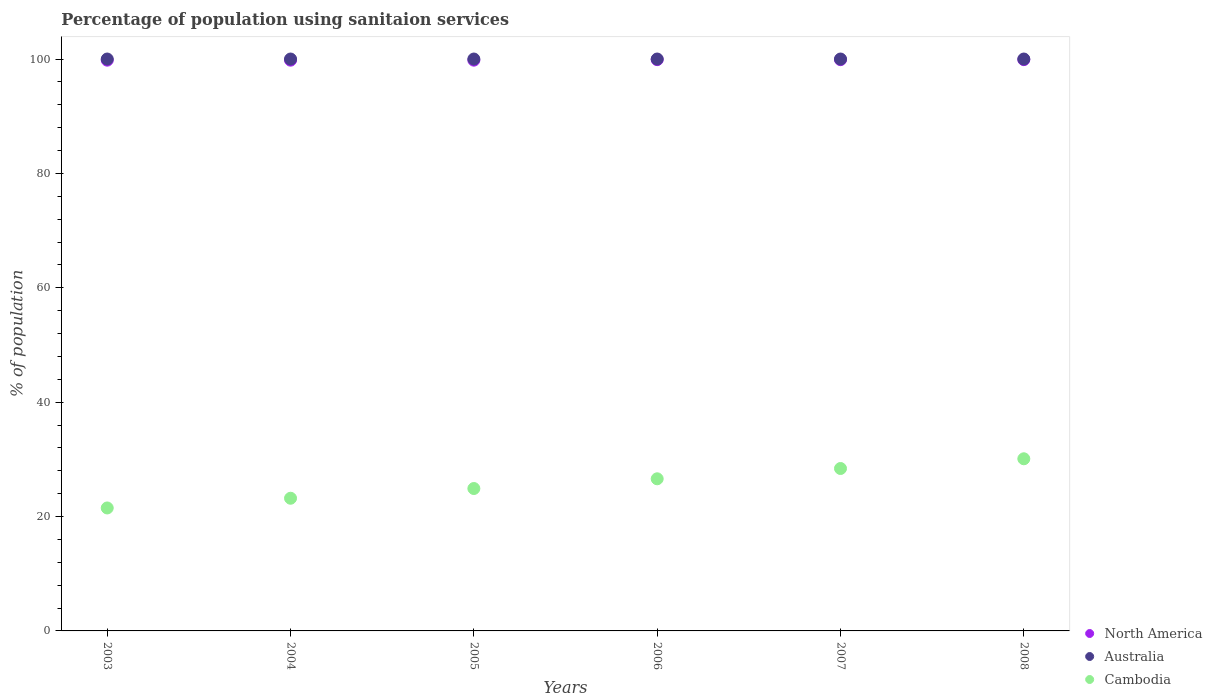How many different coloured dotlines are there?
Keep it short and to the point. 3. Is the number of dotlines equal to the number of legend labels?
Your answer should be very brief. Yes. What is the percentage of population using sanitaion services in Australia in 2004?
Your response must be concise. 100. Across all years, what is the maximum percentage of population using sanitaion services in Australia?
Your answer should be compact. 100. Across all years, what is the minimum percentage of population using sanitaion services in Cambodia?
Keep it short and to the point. 21.5. In which year was the percentage of population using sanitaion services in Cambodia maximum?
Ensure brevity in your answer.  2008. In which year was the percentage of population using sanitaion services in Cambodia minimum?
Offer a terse response. 2003. What is the total percentage of population using sanitaion services in North America in the graph?
Your response must be concise. 599.07. What is the difference between the percentage of population using sanitaion services in Cambodia in 2003 and the percentage of population using sanitaion services in Australia in 2008?
Your response must be concise. -78.5. In the year 2008, what is the difference between the percentage of population using sanitaion services in North America and percentage of population using sanitaion services in Australia?
Provide a short and direct response. -0.11. What is the ratio of the percentage of population using sanitaion services in Cambodia in 2003 to that in 2005?
Keep it short and to the point. 0.86. What is the difference between the highest and the lowest percentage of population using sanitaion services in Cambodia?
Provide a short and direct response. 8.6. In how many years, is the percentage of population using sanitaion services in Cambodia greater than the average percentage of population using sanitaion services in Cambodia taken over all years?
Keep it short and to the point. 3. Does the percentage of population using sanitaion services in North America monotonically increase over the years?
Offer a terse response. No. Is the percentage of population using sanitaion services in Australia strictly less than the percentage of population using sanitaion services in Cambodia over the years?
Make the answer very short. No. How many dotlines are there?
Ensure brevity in your answer.  3. What is the difference between two consecutive major ticks on the Y-axis?
Your answer should be very brief. 20. Does the graph contain grids?
Offer a terse response. No. Where does the legend appear in the graph?
Keep it short and to the point. Bottom right. How many legend labels are there?
Keep it short and to the point. 3. How are the legend labels stacked?
Offer a very short reply. Vertical. What is the title of the graph?
Make the answer very short. Percentage of population using sanitaion services. What is the label or title of the X-axis?
Offer a very short reply. Years. What is the label or title of the Y-axis?
Your answer should be very brief. % of population. What is the % of population of North America in 2003?
Give a very brief answer. 99.8. What is the % of population of North America in 2004?
Keep it short and to the point. 99.8. What is the % of population in Australia in 2004?
Ensure brevity in your answer.  100. What is the % of population of Cambodia in 2004?
Provide a succinct answer. 23.2. What is the % of population in North America in 2005?
Your answer should be compact. 99.8. What is the % of population in Australia in 2005?
Offer a very short reply. 100. What is the % of population of Cambodia in 2005?
Offer a very short reply. 24.9. What is the % of population of North America in 2006?
Offer a terse response. 99.89. What is the % of population in Cambodia in 2006?
Your response must be concise. 26.6. What is the % of population in North America in 2007?
Provide a succinct answer. 99.89. What is the % of population in Australia in 2007?
Make the answer very short. 100. What is the % of population in Cambodia in 2007?
Provide a succinct answer. 28.4. What is the % of population of North America in 2008?
Your answer should be compact. 99.89. What is the % of population in Cambodia in 2008?
Make the answer very short. 30.1. Across all years, what is the maximum % of population of North America?
Give a very brief answer. 99.89. Across all years, what is the maximum % of population in Cambodia?
Your response must be concise. 30.1. Across all years, what is the minimum % of population of North America?
Your response must be concise. 99.8. Across all years, what is the minimum % of population in Cambodia?
Provide a succinct answer. 21.5. What is the total % of population in North America in the graph?
Provide a succinct answer. 599.07. What is the total % of population of Australia in the graph?
Your answer should be very brief. 600. What is the total % of population in Cambodia in the graph?
Ensure brevity in your answer.  154.7. What is the difference between the % of population of Australia in 2003 and that in 2004?
Keep it short and to the point. 0. What is the difference between the % of population in Cambodia in 2003 and that in 2004?
Your response must be concise. -1.7. What is the difference between the % of population in Cambodia in 2003 and that in 2005?
Provide a succinct answer. -3.4. What is the difference between the % of population of North America in 2003 and that in 2006?
Give a very brief answer. -0.09. What is the difference between the % of population in North America in 2003 and that in 2007?
Offer a very short reply. -0.09. What is the difference between the % of population of North America in 2003 and that in 2008?
Provide a short and direct response. -0.09. What is the difference between the % of population in Australia in 2004 and that in 2005?
Make the answer very short. 0. What is the difference between the % of population in North America in 2004 and that in 2006?
Your answer should be compact. -0.09. What is the difference between the % of population of Australia in 2004 and that in 2006?
Your answer should be compact. 0. What is the difference between the % of population of Cambodia in 2004 and that in 2006?
Give a very brief answer. -3.4. What is the difference between the % of population in North America in 2004 and that in 2007?
Provide a short and direct response. -0.09. What is the difference between the % of population of Cambodia in 2004 and that in 2007?
Offer a terse response. -5.2. What is the difference between the % of population in North America in 2004 and that in 2008?
Provide a short and direct response. -0.09. What is the difference between the % of population of North America in 2005 and that in 2006?
Your response must be concise. -0.09. What is the difference between the % of population in Australia in 2005 and that in 2006?
Provide a succinct answer. 0. What is the difference between the % of population in Cambodia in 2005 and that in 2006?
Ensure brevity in your answer.  -1.7. What is the difference between the % of population in North America in 2005 and that in 2007?
Ensure brevity in your answer.  -0.09. What is the difference between the % of population of Australia in 2005 and that in 2007?
Keep it short and to the point. 0. What is the difference between the % of population in North America in 2005 and that in 2008?
Keep it short and to the point. -0.09. What is the difference between the % of population of Australia in 2005 and that in 2008?
Provide a succinct answer. 0. What is the difference between the % of population in North America in 2006 and that in 2007?
Your answer should be compact. 0. What is the difference between the % of population of Cambodia in 2006 and that in 2008?
Ensure brevity in your answer.  -3.5. What is the difference between the % of population of Australia in 2007 and that in 2008?
Offer a terse response. 0. What is the difference between the % of population of North America in 2003 and the % of population of Australia in 2004?
Make the answer very short. -0.2. What is the difference between the % of population of North America in 2003 and the % of population of Cambodia in 2004?
Offer a terse response. 76.6. What is the difference between the % of population in Australia in 2003 and the % of population in Cambodia in 2004?
Give a very brief answer. 76.8. What is the difference between the % of population of North America in 2003 and the % of population of Cambodia in 2005?
Offer a very short reply. 74.9. What is the difference between the % of population in Australia in 2003 and the % of population in Cambodia in 2005?
Make the answer very short. 75.1. What is the difference between the % of population of North America in 2003 and the % of population of Cambodia in 2006?
Provide a short and direct response. 73.2. What is the difference between the % of population in Australia in 2003 and the % of population in Cambodia in 2006?
Give a very brief answer. 73.4. What is the difference between the % of population of North America in 2003 and the % of population of Cambodia in 2007?
Offer a very short reply. 71.4. What is the difference between the % of population of Australia in 2003 and the % of population of Cambodia in 2007?
Your response must be concise. 71.6. What is the difference between the % of population of North America in 2003 and the % of population of Cambodia in 2008?
Offer a terse response. 69.7. What is the difference between the % of population of Australia in 2003 and the % of population of Cambodia in 2008?
Provide a short and direct response. 69.9. What is the difference between the % of population in North America in 2004 and the % of population in Cambodia in 2005?
Give a very brief answer. 74.9. What is the difference between the % of population in Australia in 2004 and the % of population in Cambodia in 2005?
Your answer should be compact. 75.1. What is the difference between the % of population of North America in 2004 and the % of population of Australia in 2006?
Ensure brevity in your answer.  -0.2. What is the difference between the % of population of North America in 2004 and the % of population of Cambodia in 2006?
Offer a very short reply. 73.2. What is the difference between the % of population of Australia in 2004 and the % of population of Cambodia in 2006?
Ensure brevity in your answer.  73.4. What is the difference between the % of population of North America in 2004 and the % of population of Cambodia in 2007?
Your response must be concise. 71.4. What is the difference between the % of population in Australia in 2004 and the % of population in Cambodia in 2007?
Ensure brevity in your answer.  71.6. What is the difference between the % of population in North America in 2004 and the % of population in Australia in 2008?
Offer a terse response. -0.2. What is the difference between the % of population of North America in 2004 and the % of population of Cambodia in 2008?
Give a very brief answer. 69.7. What is the difference between the % of population of Australia in 2004 and the % of population of Cambodia in 2008?
Ensure brevity in your answer.  69.9. What is the difference between the % of population in North America in 2005 and the % of population in Cambodia in 2006?
Your response must be concise. 73.2. What is the difference between the % of population of Australia in 2005 and the % of population of Cambodia in 2006?
Your response must be concise. 73.4. What is the difference between the % of population of North America in 2005 and the % of population of Cambodia in 2007?
Keep it short and to the point. 71.4. What is the difference between the % of population of Australia in 2005 and the % of population of Cambodia in 2007?
Provide a short and direct response. 71.6. What is the difference between the % of population in North America in 2005 and the % of population in Cambodia in 2008?
Keep it short and to the point. 69.7. What is the difference between the % of population of Australia in 2005 and the % of population of Cambodia in 2008?
Your response must be concise. 69.9. What is the difference between the % of population of North America in 2006 and the % of population of Australia in 2007?
Ensure brevity in your answer.  -0.11. What is the difference between the % of population in North America in 2006 and the % of population in Cambodia in 2007?
Make the answer very short. 71.49. What is the difference between the % of population of Australia in 2006 and the % of population of Cambodia in 2007?
Keep it short and to the point. 71.6. What is the difference between the % of population in North America in 2006 and the % of population in Australia in 2008?
Offer a very short reply. -0.11. What is the difference between the % of population in North America in 2006 and the % of population in Cambodia in 2008?
Provide a short and direct response. 69.79. What is the difference between the % of population in Australia in 2006 and the % of population in Cambodia in 2008?
Make the answer very short. 69.9. What is the difference between the % of population in North America in 2007 and the % of population in Australia in 2008?
Give a very brief answer. -0.11. What is the difference between the % of population in North America in 2007 and the % of population in Cambodia in 2008?
Make the answer very short. 69.79. What is the difference between the % of population in Australia in 2007 and the % of population in Cambodia in 2008?
Offer a very short reply. 69.9. What is the average % of population in North America per year?
Provide a succinct answer. 99.85. What is the average % of population of Australia per year?
Give a very brief answer. 100. What is the average % of population in Cambodia per year?
Give a very brief answer. 25.78. In the year 2003, what is the difference between the % of population of North America and % of population of Cambodia?
Your answer should be very brief. 78.3. In the year 2003, what is the difference between the % of population of Australia and % of population of Cambodia?
Provide a succinct answer. 78.5. In the year 2004, what is the difference between the % of population of North America and % of population of Australia?
Your answer should be very brief. -0.2. In the year 2004, what is the difference between the % of population in North America and % of population in Cambodia?
Your answer should be compact. 76.6. In the year 2004, what is the difference between the % of population of Australia and % of population of Cambodia?
Keep it short and to the point. 76.8. In the year 2005, what is the difference between the % of population in North America and % of population in Cambodia?
Give a very brief answer. 74.9. In the year 2005, what is the difference between the % of population of Australia and % of population of Cambodia?
Make the answer very short. 75.1. In the year 2006, what is the difference between the % of population of North America and % of population of Australia?
Provide a succinct answer. -0.11. In the year 2006, what is the difference between the % of population in North America and % of population in Cambodia?
Offer a very short reply. 73.29. In the year 2006, what is the difference between the % of population in Australia and % of population in Cambodia?
Your answer should be very brief. 73.4. In the year 2007, what is the difference between the % of population in North America and % of population in Australia?
Your answer should be very brief. -0.11. In the year 2007, what is the difference between the % of population in North America and % of population in Cambodia?
Offer a terse response. 71.49. In the year 2007, what is the difference between the % of population of Australia and % of population of Cambodia?
Offer a terse response. 71.6. In the year 2008, what is the difference between the % of population in North America and % of population in Australia?
Ensure brevity in your answer.  -0.11. In the year 2008, what is the difference between the % of population of North America and % of population of Cambodia?
Provide a succinct answer. 69.79. In the year 2008, what is the difference between the % of population in Australia and % of population in Cambodia?
Offer a terse response. 69.9. What is the ratio of the % of population of North America in 2003 to that in 2004?
Keep it short and to the point. 1. What is the ratio of the % of population of Cambodia in 2003 to that in 2004?
Provide a succinct answer. 0.93. What is the ratio of the % of population of North America in 2003 to that in 2005?
Keep it short and to the point. 1. What is the ratio of the % of population of Cambodia in 2003 to that in 2005?
Your answer should be compact. 0.86. What is the ratio of the % of population in North America in 2003 to that in 2006?
Your response must be concise. 1. What is the ratio of the % of population in Australia in 2003 to that in 2006?
Your answer should be compact. 1. What is the ratio of the % of population in Cambodia in 2003 to that in 2006?
Your response must be concise. 0.81. What is the ratio of the % of population in North America in 2003 to that in 2007?
Your answer should be compact. 1. What is the ratio of the % of population of Australia in 2003 to that in 2007?
Keep it short and to the point. 1. What is the ratio of the % of population in Cambodia in 2003 to that in 2007?
Offer a very short reply. 0.76. What is the ratio of the % of population of North America in 2004 to that in 2005?
Make the answer very short. 1. What is the ratio of the % of population of Australia in 2004 to that in 2005?
Make the answer very short. 1. What is the ratio of the % of population of Cambodia in 2004 to that in 2005?
Give a very brief answer. 0.93. What is the ratio of the % of population of Australia in 2004 to that in 2006?
Offer a terse response. 1. What is the ratio of the % of population of Cambodia in 2004 to that in 2006?
Provide a succinct answer. 0.87. What is the ratio of the % of population of North America in 2004 to that in 2007?
Ensure brevity in your answer.  1. What is the ratio of the % of population in Australia in 2004 to that in 2007?
Offer a terse response. 1. What is the ratio of the % of population in Cambodia in 2004 to that in 2007?
Your answer should be compact. 0.82. What is the ratio of the % of population in Cambodia in 2004 to that in 2008?
Offer a terse response. 0.77. What is the ratio of the % of population in North America in 2005 to that in 2006?
Your answer should be very brief. 1. What is the ratio of the % of population in Cambodia in 2005 to that in 2006?
Your answer should be very brief. 0.94. What is the ratio of the % of population of Australia in 2005 to that in 2007?
Your answer should be compact. 1. What is the ratio of the % of population of Cambodia in 2005 to that in 2007?
Make the answer very short. 0.88. What is the ratio of the % of population in Australia in 2005 to that in 2008?
Keep it short and to the point. 1. What is the ratio of the % of population in Cambodia in 2005 to that in 2008?
Your answer should be compact. 0.83. What is the ratio of the % of population in North America in 2006 to that in 2007?
Offer a terse response. 1. What is the ratio of the % of population in Cambodia in 2006 to that in 2007?
Offer a very short reply. 0.94. What is the ratio of the % of population of Australia in 2006 to that in 2008?
Provide a succinct answer. 1. What is the ratio of the % of population in Cambodia in 2006 to that in 2008?
Your answer should be compact. 0.88. What is the ratio of the % of population in North America in 2007 to that in 2008?
Your response must be concise. 1. What is the ratio of the % of population of Australia in 2007 to that in 2008?
Your answer should be very brief. 1. What is the ratio of the % of population in Cambodia in 2007 to that in 2008?
Your response must be concise. 0.94. What is the difference between the highest and the second highest % of population of North America?
Offer a very short reply. 0. What is the difference between the highest and the lowest % of population in North America?
Ensure brevity in your answer.  0.09. 